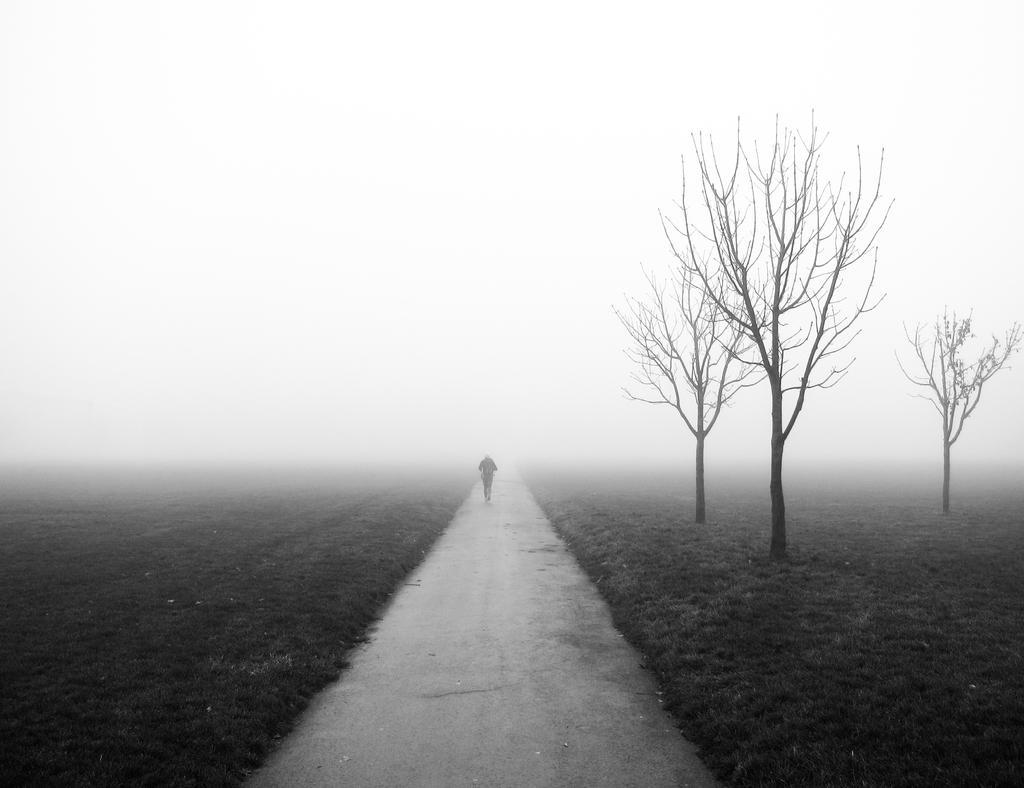Can you describe this image briefly? In this picture there is a man in the center of the image, on the way and there is greenery on the right and left side of the image. 